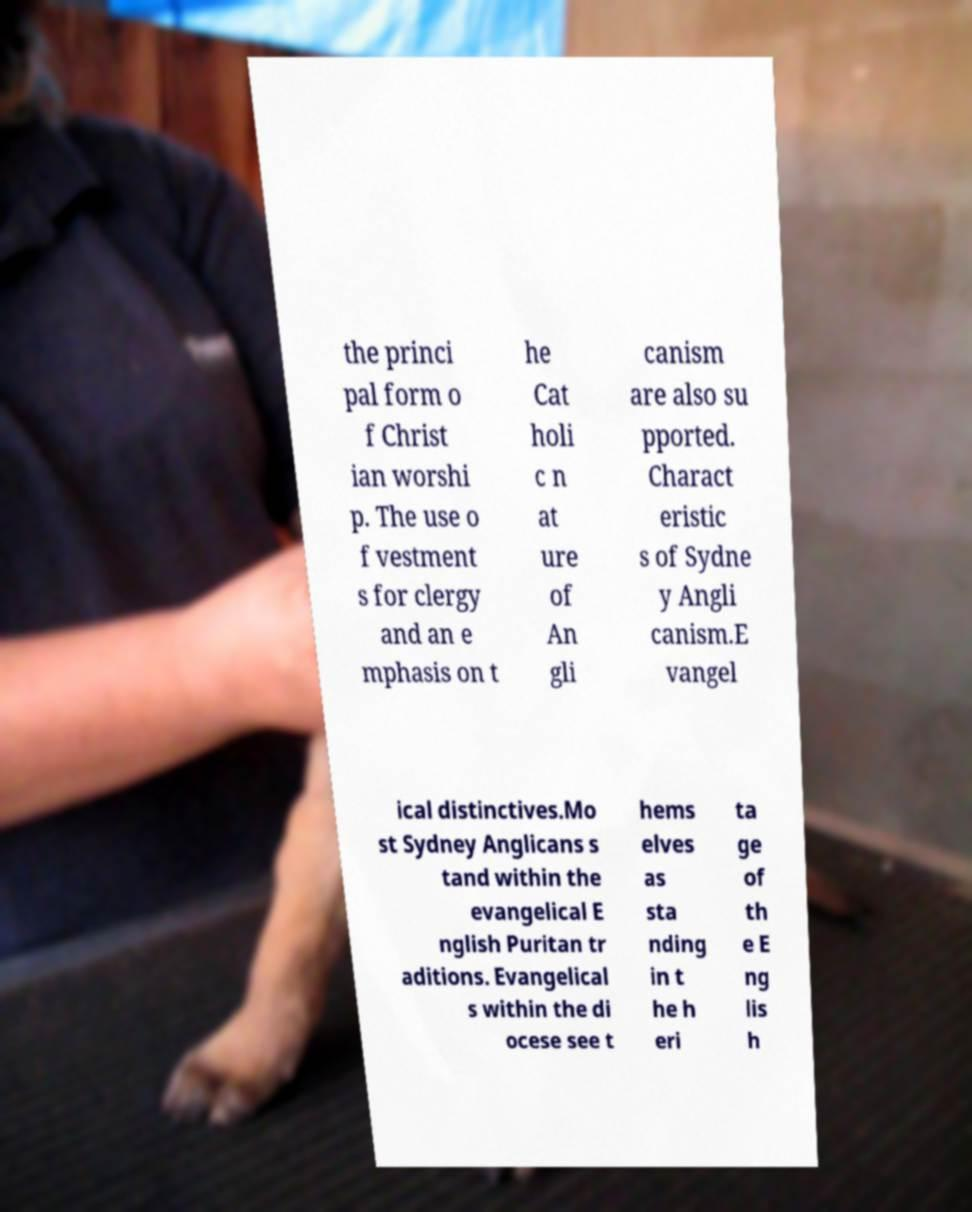Can you accurately transcribe the text from the provided image for me? the princi pal form o f Christ ian worshi p. The use o f vestment s for clergy and an e mphasis on t he Cat holi c n at ure of An gli canism are also su pported. Charact eristic s of Sydne y Angli canism.E vangel ical distinctives.Mo st Sydney Anglicans s tand within the evangelical E nglish Puritan tr aditions. Evangelical s within the di ocese see t hems elves as sta nding in t he h eri ta ge of th e E ng lis h 